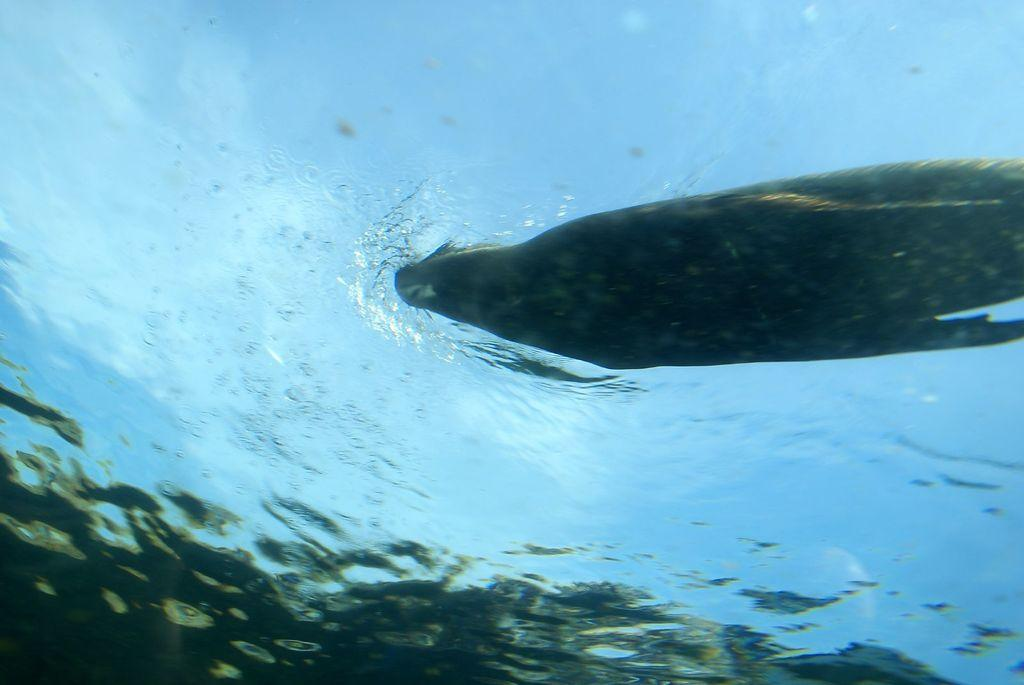What animal can be seen in the image? There is a seal in the image. Where is the seal located? The seal is in the water. What other creatures are present in the image? There are fishes in the image. How are the fishes positioned in relation to the seal? The fishes are below the seal. What type of scissors can be seen in the image? There are no scissors present in the image. How does the scarecrow protect the fishes from the seal in the image? There is no scarecrow present in the image, and the fishes are not being protected from the seal. 